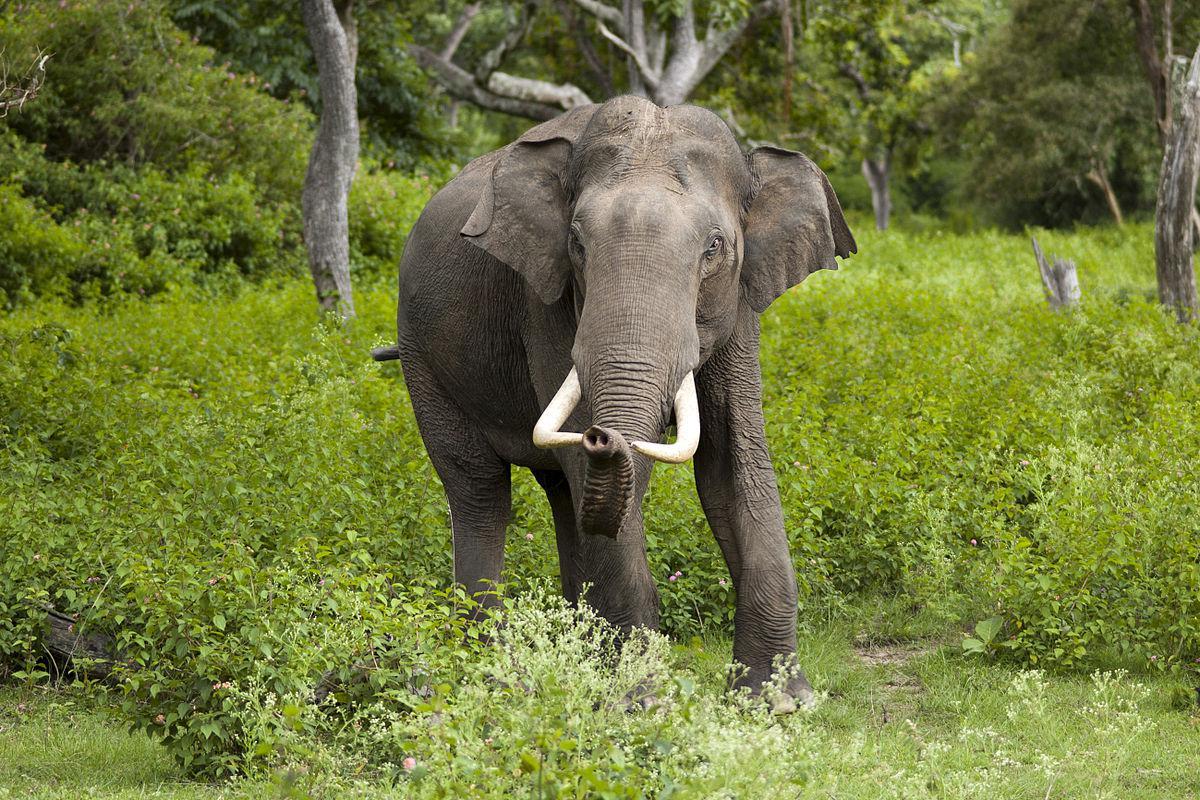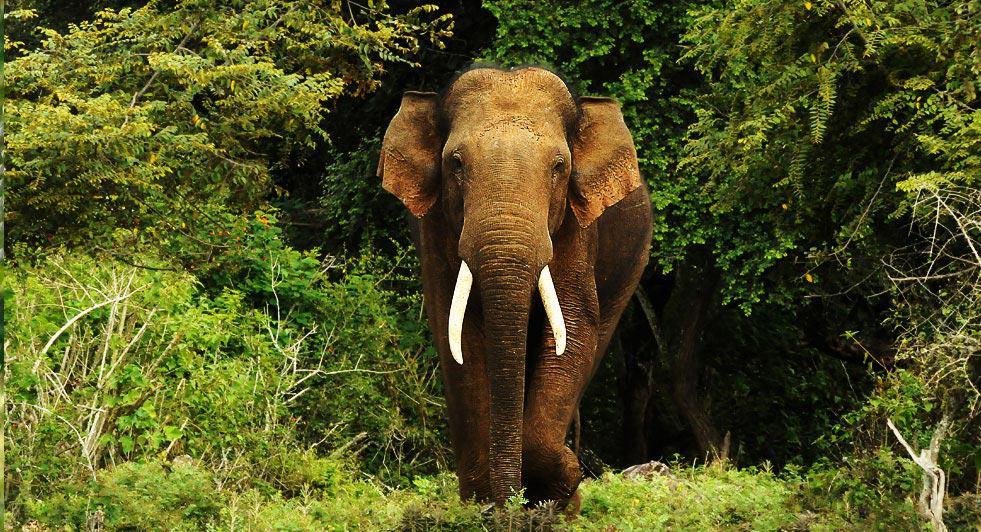The first image is the image on the left, the second image is the image on the right. Evaluate the accuracy of this statement regarding the images: "The right image shows an elephant with large tusks.". Is it true? Answer yes or no. Yes. 